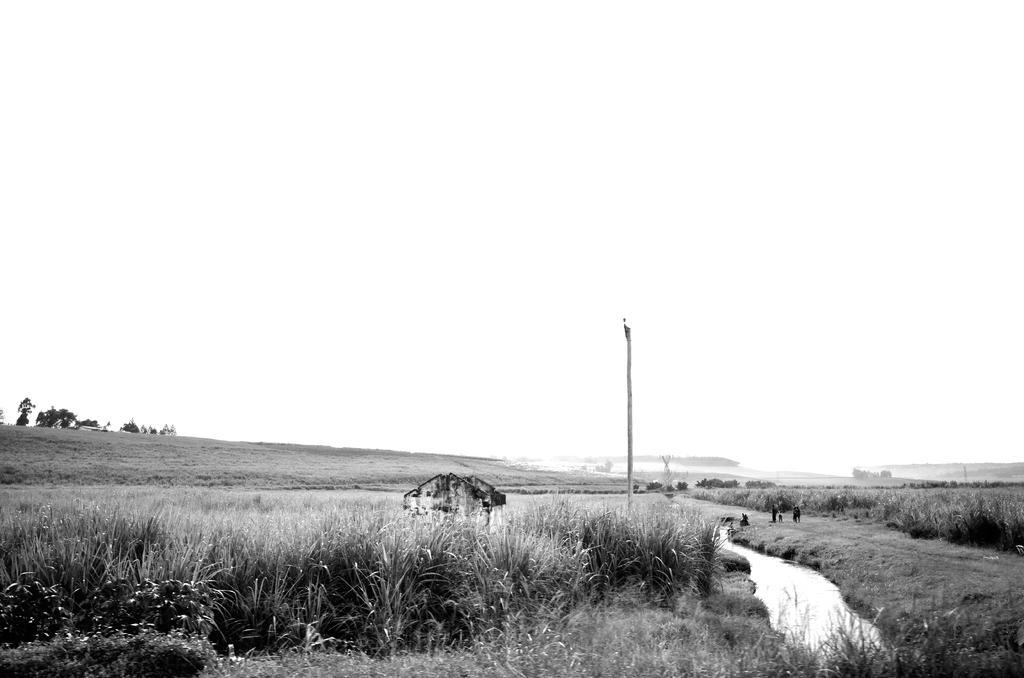Please provide a concise description of this image. This image is a black and white image. This image is taken outdoors. At the top of the image there is the sky. At the bottom of the image there is a ground with grass on it. In the background there is a ground with grass on it and there are a few trees on the ground and there are few plants. On the left and right sides of the image there are few fields. In the middle of the image there is a hut and there is a pole. There is a lake with water. 